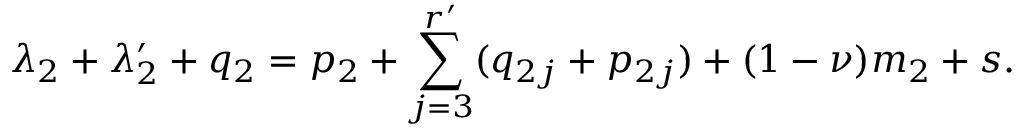Convert formula to latex. <formula><loc_0><loc_0><loc_500><loc_500>\lambda _ { 2 } + \lambda _ { 2 } ^ { \prime } + q _ { 2 } = p _ { 2 } + \sum _ { j = 3 } ^ { r ^ { \prime } } ( q _ { 2 j } + p _ { 2 j } ) + ( 1 - \nu ) m _ { 2 } + s .</formula> 